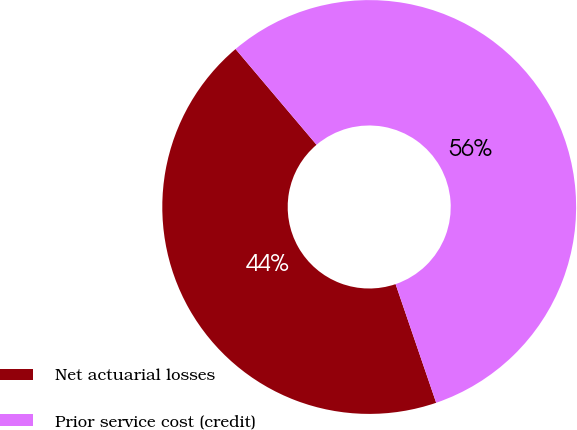<chart> <loc_0><loc_0><loc_500><loc_500><pie_chart><fcel>Net actuarial losses<fcel>Prior service cost (credit)<nl><fcel>44.07%<fcel>55.93%<nl></chart> 